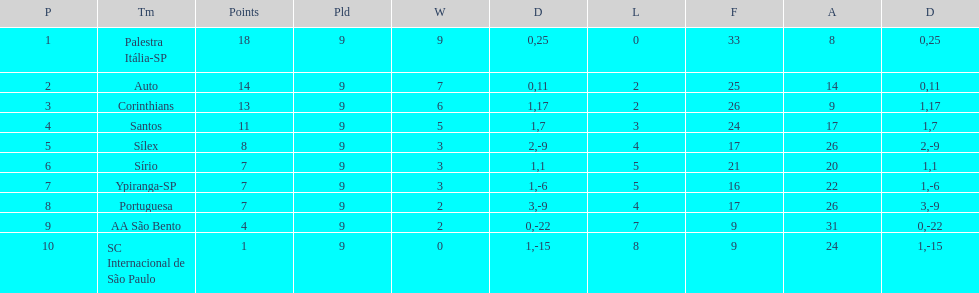Which brazilian team took the top spot in the 1926 brazilian football cup? Palestra Itália-SP. 